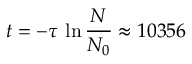<formula> <loc_0><loc_0><loc_500><loc_500>t = - \tau \, \ln { \frac { N } { N _ { 0 } } } \approx 1 0 3 5 6</formula> 